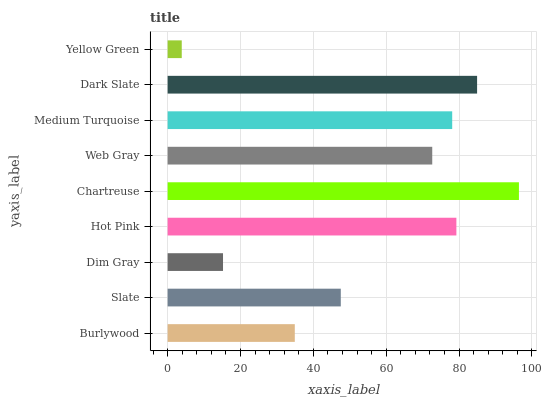Is Yellow Green the minimum?
Answer yes or no. Yes. Is Chartreuse the maximum?
Answer yes or no. Yes. Is Slate the minimum?
Answer yes or no. No. Is Slate the maximum?
Answer yes or no. No. Is Slate greater than Burlywood?
Answer yes or no. Yes. Is Burlywood less than Slate?
Answer yes or no. Yes. Is Burlywood greater than Slate?
Answer yes or no. No. Is Slate less than Burlywood?
Answer yes or no. No. Is Web Gray the high median?
Answer yes or no. Yes. Is Web Gray the low median?
Answer yes or no. Yes. Is Slate the high median?
Answer yes or no. No. Is Medium Turquoise the low median?
Answer yes or no. No. 